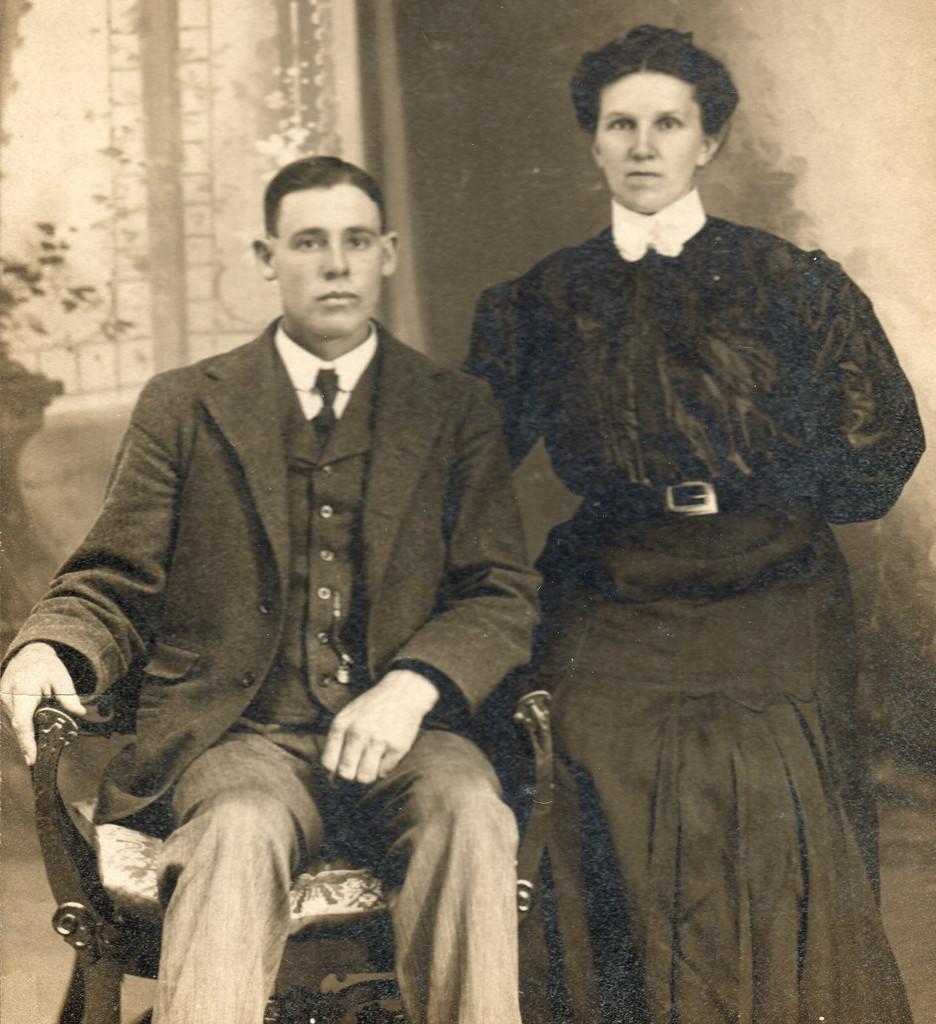Describe this image in one or two sentences. In this image we can see black and white picture of two people. One person is sitting on a chair and a woman is standing beside him. In the background, we can see a plant, window and a wall. 